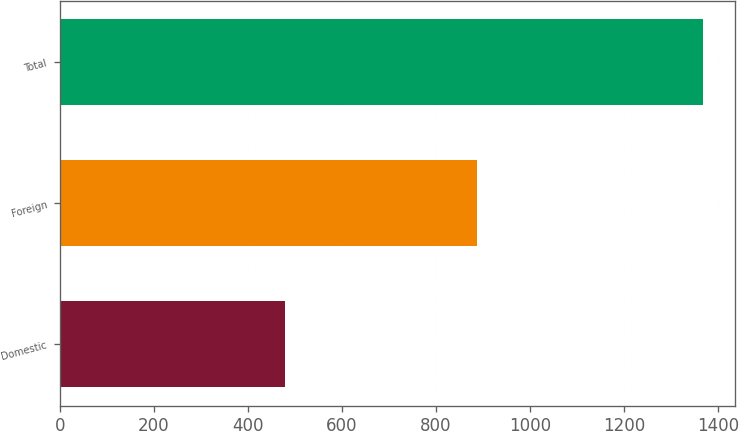Convert chart to OTSL. <chart><loc_0><loc_0><loc_500><loc_500><bar_chart><fcel>Domestic<fcel>Foreign<fcel>Total<nl><fcel>480<fcel>888<fcel>1368<nl></chart> 